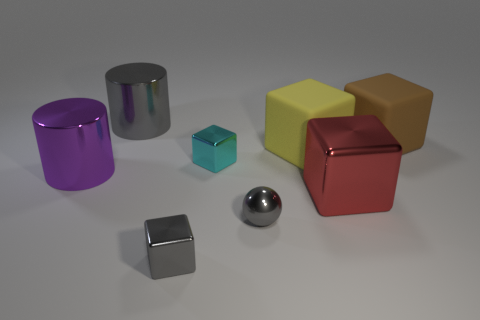Subtract all brown cubes. How many cubes are left? 4 Subtract 1 blocks. How many blocks are left? 4 Subtract all cyan cubes. How many cubes are left? 4 Add 2 big purple metallic objects. How many objects exist? 10 Subtract all brown blocks. Subtract all purple cylinders. How many blocks are left? 4 Subtract all cylinders. How many objects are left? 6 Add 3 small green matte cylinders. How many small green matte cylinders exist? 3 Subtract 0 blue spheres. How many objects are left? 8 Subtract all cyan shiny things. Subtract all large yellow things. How many objects are left? 6 Add 3 large purple shiny things. How many large purple shiny things are left? 4 